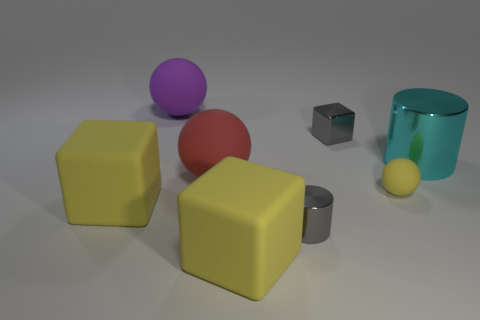Add 1 small gray shiny cylinders. How many objects exist? 9 Subtract all balls. How many objects are left? 5 Subtract all shiny things. Subtract all large brown metallic cylinders. How many objects are left? 5 Add 2 yellow objects. How many yellow objects are left? 5 Add 3 big things. How many big things exist? 8 Subtract 0 brown cubes. How many objects are left? 8 